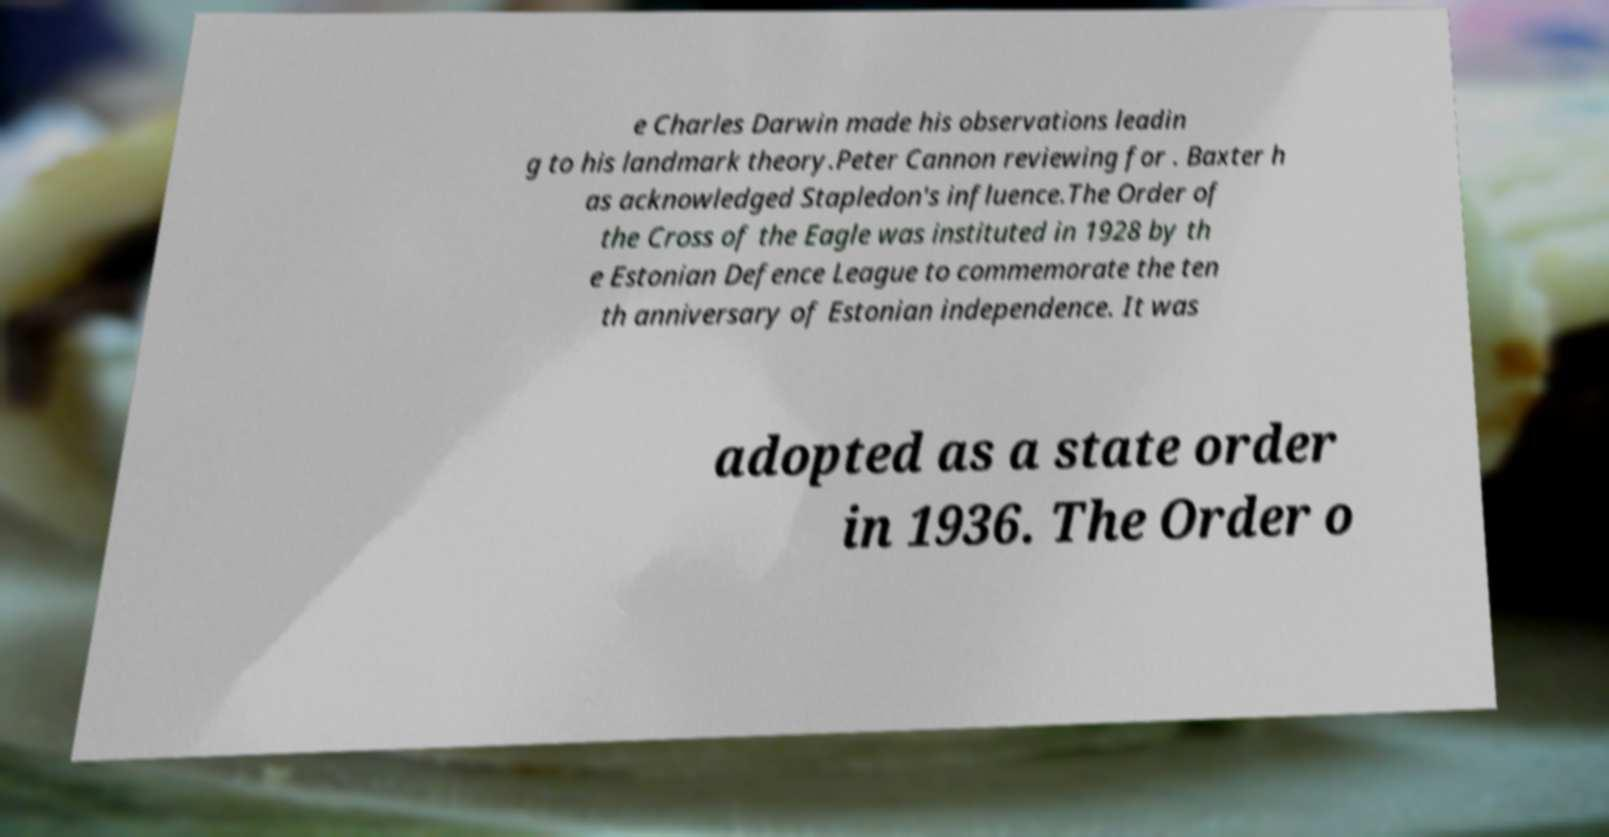Could you extract and type out the text from this image? e Charles Darwin made his observations leadin g to his landmark theory.Peter Cannon reviewing for . Baxter h as acknowledged Stapledon's influence.The Order of the Cross of the Eagle was instituted in 1928 by th e Estonian Defence League to commemorate the ten th anniversary of Estonian independence. It was adopted as a state order in 1936. The Order o 